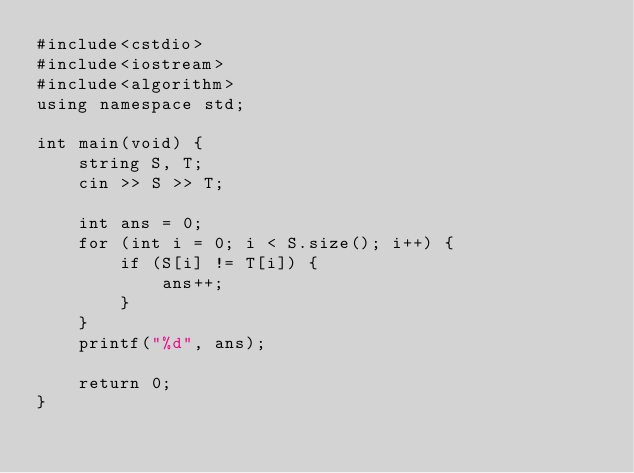Convert code to text. <code><loc_0><loc_0><loc_500><loc_500><_C++_>#include<cstdio>
#include<iostream>
#include<algorithm>
using namespace std;

int main(void) {
	string S, T;
	cin >> S >> T;

	int ans = 0;
	for (int i = 0; i < S.size(); i++) {
		if (S[i] != T[i]) {
			ans++;
		}
	}
	printf("%d", ans);

	return 0;
}
</code> 